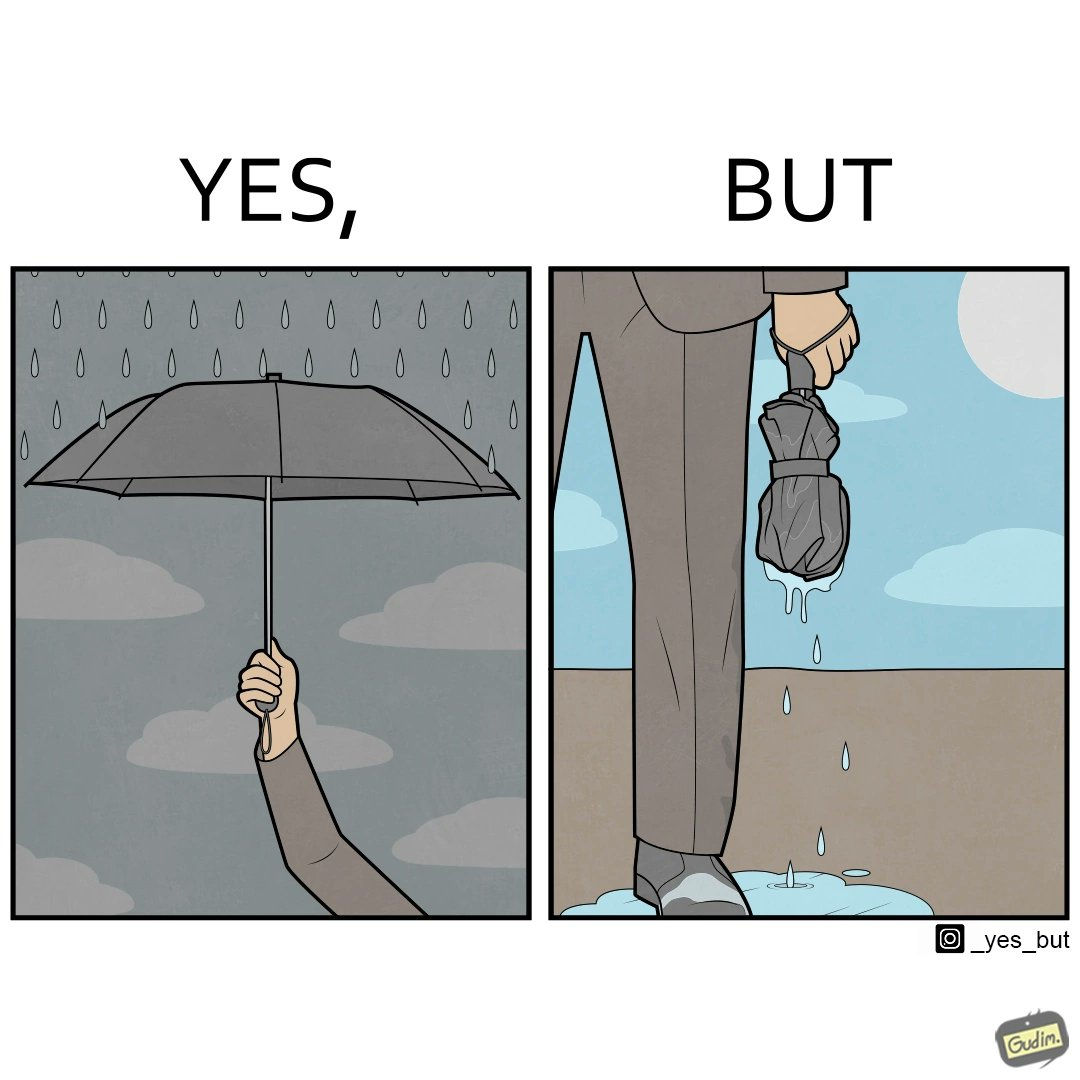What is shown in this image? The image is funny because while the umbrella helps a person avoid getting wet from rain, when the rain stops and the umbrella is folded, the wet umbrella iteself drips water on the person holding it. 